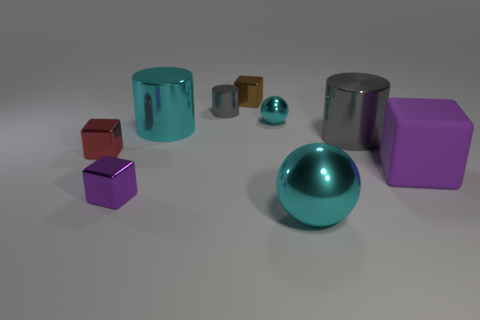There is a big cube; does it have the same color as the small shiny cube that is in front of the tiny red object?
Ensure brevity in your answer.  Yes. How many objects are either tiny spheres or small metal balls to the left of the big cyan sphere?
Your answer should be compact. 1. There is a gray thing on the right side of the metal cube that is behind the big gray metallic thing; how big is it?
Give a very brief answer. Large. Are there the same number of small metal cylinders left of the cyan cylinder and cylinders on the left side of the matte object?
Offer a very short reply. No. There is a purple thing that is right of the large metallic ball; are there any tiny metallic cylinders that are left of it?
Ensure brevity in your answer.  Yes. What is the shape of the purple thing that is the same material as the brown block?
Keep it short and to the point. Cube. Is there anything else that is the same color as the big metallic ball?
Give a very brief answer. Yes. What is the material of the purple cube that is on the right side of the metal cube right of the small purple metallic object?
Ensure brevity in your answer.  Rubber. Is there a large green shiny object that has the same shape as the brown shiny object?
Offer a very short reply. No. What number of other objects are there of the same shape as the big gray object?
Your response must be concise. 2. 